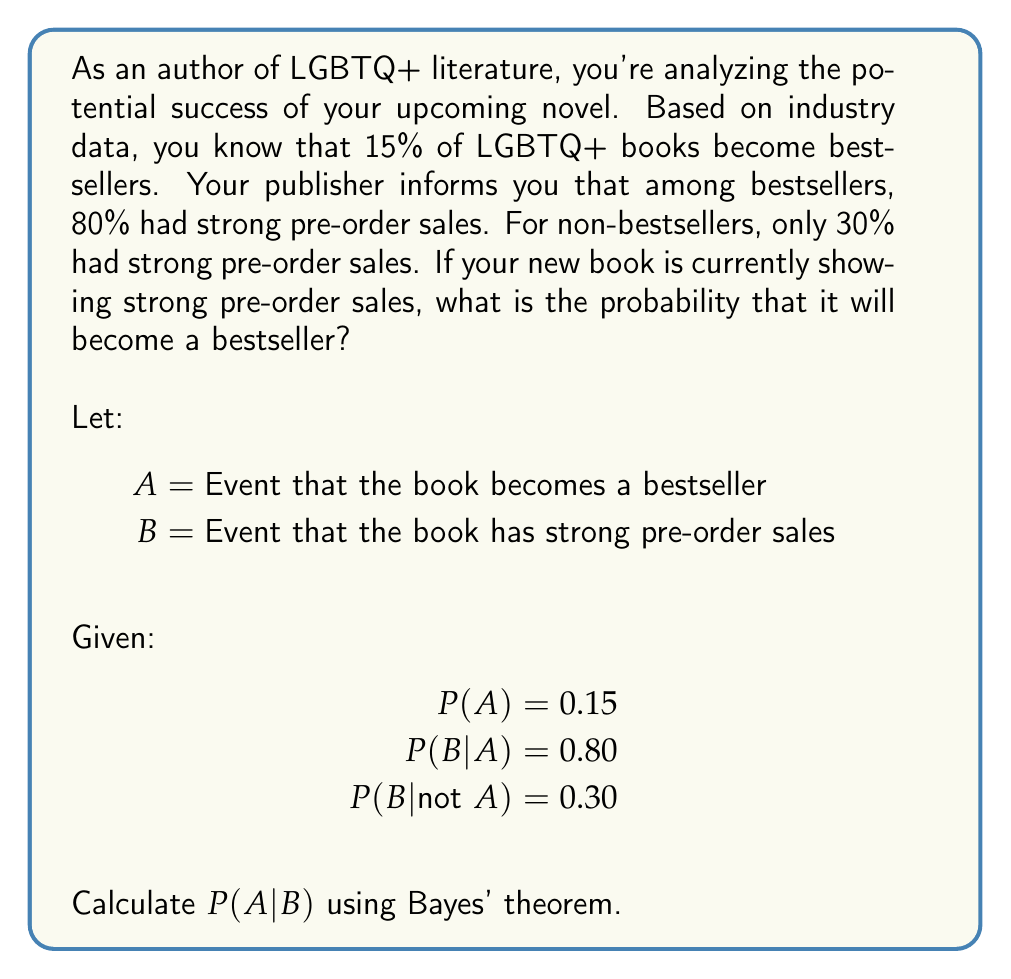Help me with this question. To solve this problem, we'll use Bayes' theorem:

$$ P(A|B) = \frac{P(B|A) \cdot P(A)}{P(B)} $$

Step 1: We're given P(A), P(B|A), and P(B|not A). We need to calculate P(B).

Step 2: Calculate P(B) using the law of total probability:
$$ P(B) = P(B|A) \cdot P(A) + P(B|not A) \cdot P(not A) $$
$$ P(B) = 0.80 \cdot 0.15 + 0.30 \cdot (1 - 0.15) $$
$$ P(B) = 0.12 + 0.255 = 0.375 $$

Step 3: Now we can apply Bayes' theorem:
$$ P(A|B) = \frac{0.80 \cdot 0.15}{0.375} = \frac{0.12}{0.375} = 0.32 $$

Therefore, given strong pre-order sales, the probability that your book will become a bestseller is 0.32 or 32%.
Answer: 0.32 